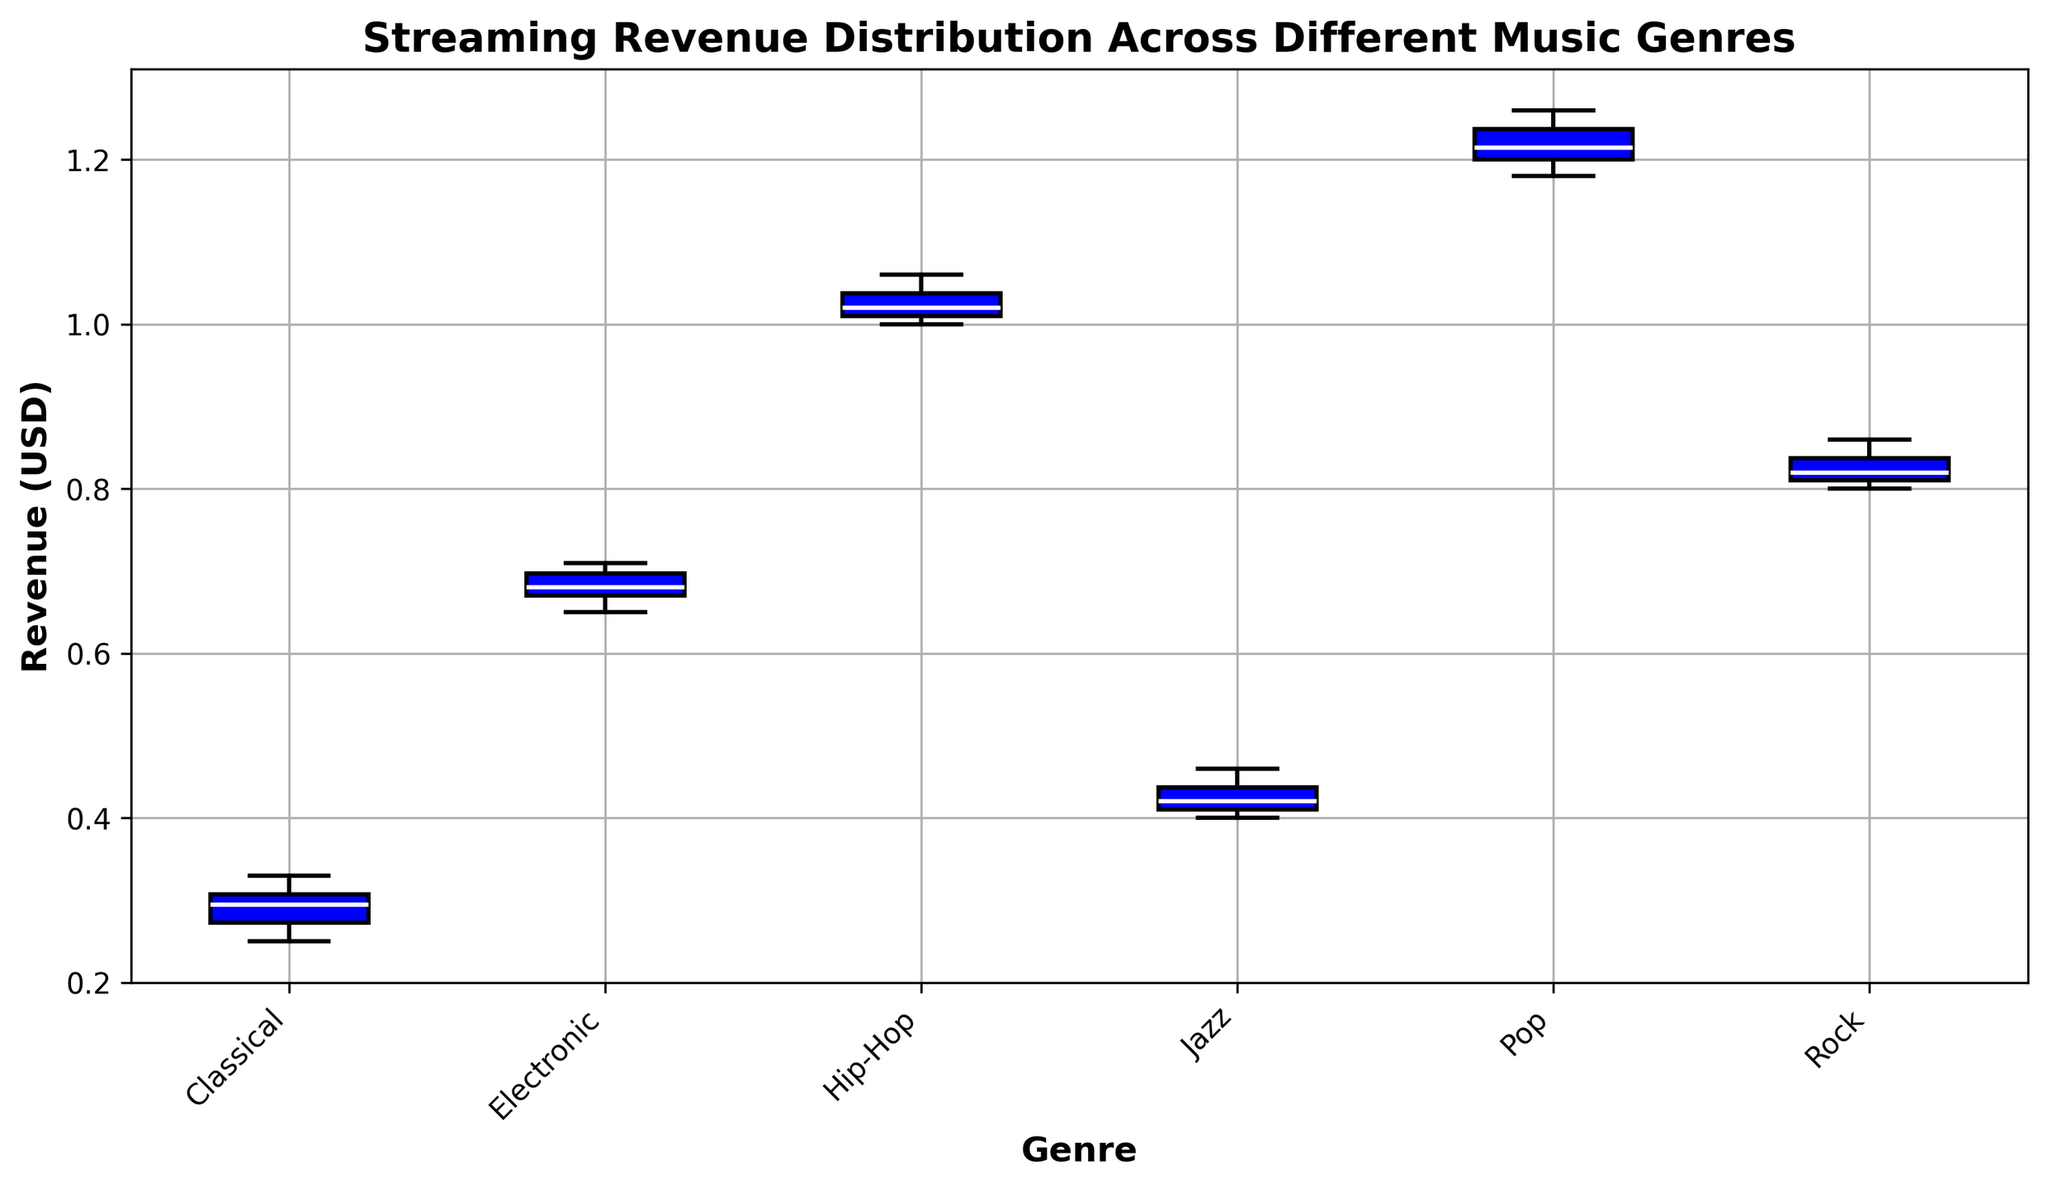What genre has the highest median streaming revenue? By looking at the box plot, identify the genre with the highest central line within the box, which represents the median value.
Answer: Pop Which genre's box plot has the smallest interquartile range (IQR) for streaming revenue? The IQR is represented by the height of the box in the plot. Identify the genre with the shortest box.
Answer: Classical Between Rock and Jazz, which genre has a higher third quartile (top of the box)? Compare the top edges of the boxes for Rock and Jazz. Identify which one is higher.
Answer: Rock Is the median streaming revenue for Electronic higher or lower than the median for Hip-Hop? Compare the central lines within the boxes for Electronic and Hip-Hop. Identify whether Electronic's median line is higher or lower.
Answer: Lower What is the difference between the maximum streaming revenue in Pop and the maximum in Classical? Identify the top whiskers (lines extending from the top of the box) for Pop and Classical, then subtract the maximum value of Classical from that of Pop.
Answer: 0.95 How does the range of revenues for Jazz compare to that for Rock? Look at the distance between the top and bottom whiskers for both Jazz and Rock. Compare these distances visually.
Answer: Jazz has a smaller range than Rock Which genre shows more outliers in the distribution of streaming revenues? Look for red circles (outliers) in the plot and count the number associated with each genre.
Answer: No genre has outliers Which genre has a minimum revenue closest to $0.40? Identify the bottom whiskers for each genre and identify the one closest to $0.40.
Answer: Jazz Is the median streaming revenue for Classical above or below $0.30? Locate the central line within the Classical box and determine whether it's above or below the $0.30 mark on the y-axis.
Answer: Above Compare the median values of Pop and Hip-Hop streaming revenues. Which is greater, and by how much? Locate the central lines within the boxes for Pop and Hip-Hop, then compute the difference between these median values.
Answer: Pop is greater by 0.18 